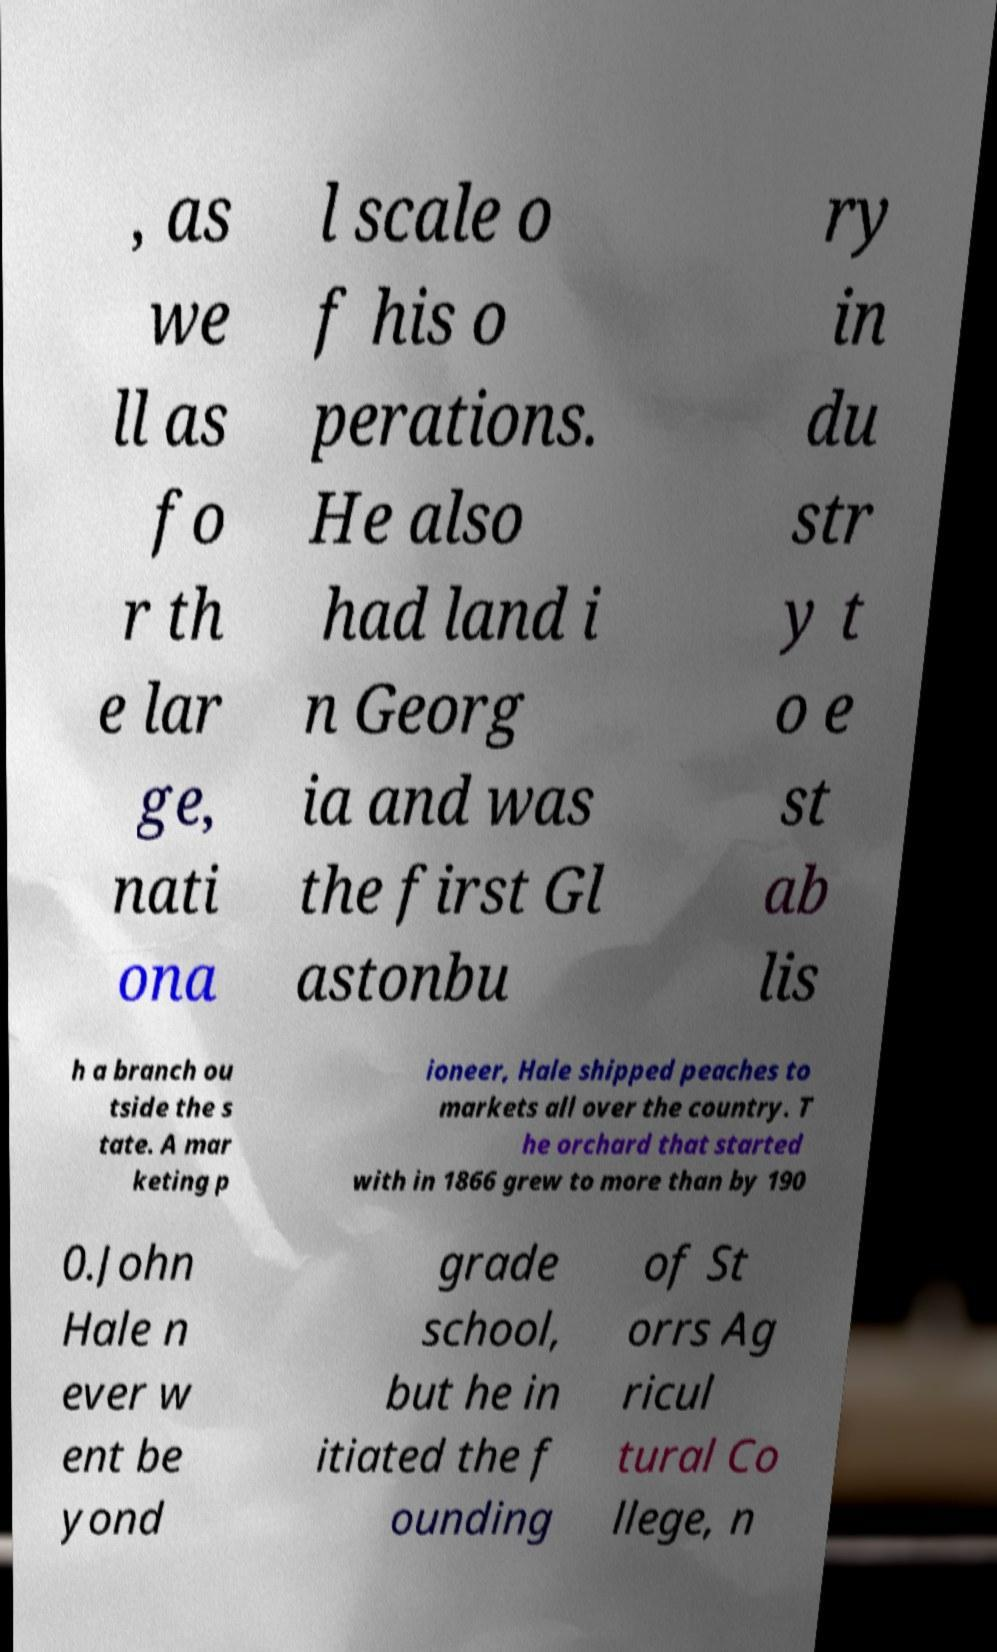For documentation purposes, I need the text within this image transcribed. Could you provide that? , as we ll as fo r th e lar ge, nati ona l scale o f his o perations. He also had land i n Georg ia and was the first Gl astonbu ry in du str y t o e st ab lis h a branch ou tside the s tate. A mar keting p ioneer, Hale shipped peaches to markets all over the country. T he orchard that started with in 1866 grew to more than by 190 0.John Hale n ever w ent be yond grade school, but he in itiated the f ounding of St orrs Ag ricul tural Co llege, n 